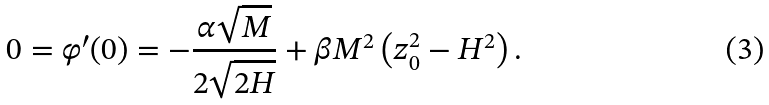<formula> <loc_0><loc_0><loc_500><loc_500>0 = \varphi ^ { \prime } ( 0 ) = - \frac { \alpha \sqrt { M } } { 2 \sqrt { 2 H } } + \beta M ^ { 2 } \left ( z _ { 0 } ^ { 2 } - H ^ { 2 } \right ) .</formula> 